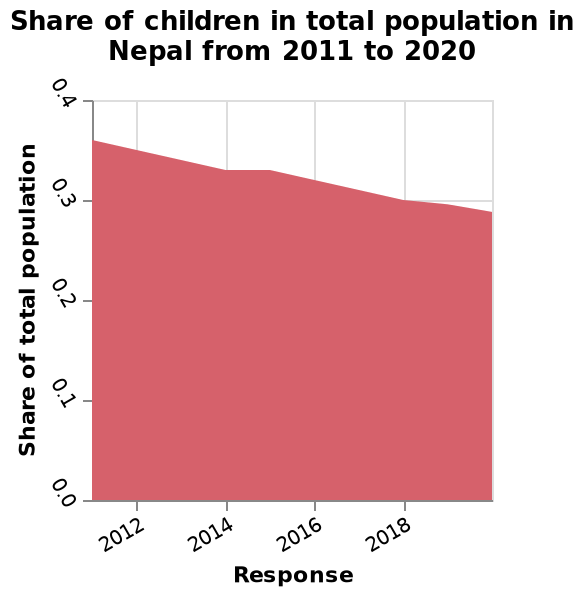<image>
What has been the trend in the share of children in the total population in Nepal over the past ten years? The share of children in the total population in Nepal has been declining steadily over the past ten years. What does the y-axis measure and what are its minimum and maximum values?  The y-axis measures "Share of total population" along a linear scale with a minimum value of 0.0 and a maximum value of 0.4. What was the share of children in the total population in Nepal by 2020? By 2020, the share of children in the total population in Nepal had dropped to less than 0.3. Has the share of children in the total population in Nepal increased or decreased in the past ten years? The share of children in the total population in Nepal has decreased in the past ten years. Has the share of children in the total population in Nepal been increasing steadily over the past ten years? No.The share of children in the total population in Nepal has been declining steadily over the past ten years. 